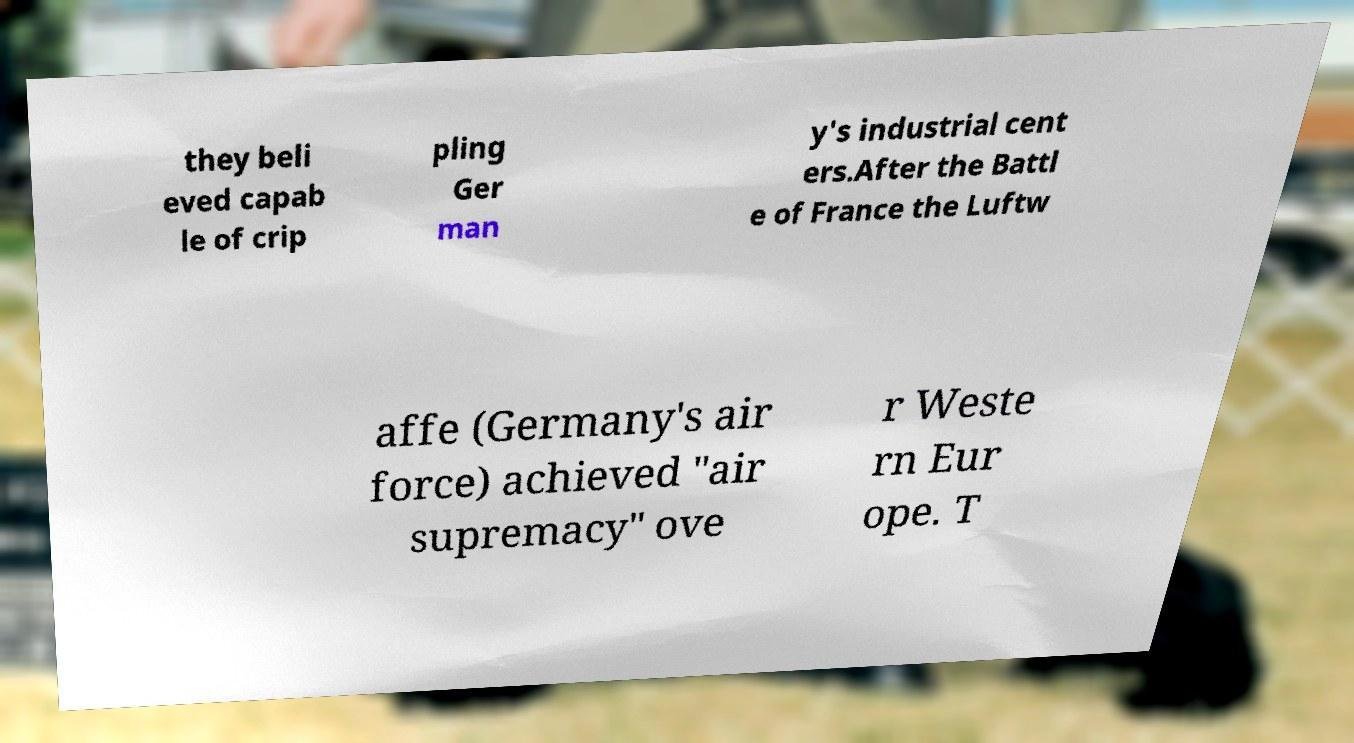Can you read and provide the text displayed in the image?This photo seems to have some interesting text. Can you extract and type it out for me? they beli eved capab le of crip pling Ger man y's industrial cent ers.After the Battl e of France the Luftw affe (Germany's air force) achieved "air supremacy" ove r Weste rn Eur ope. T 